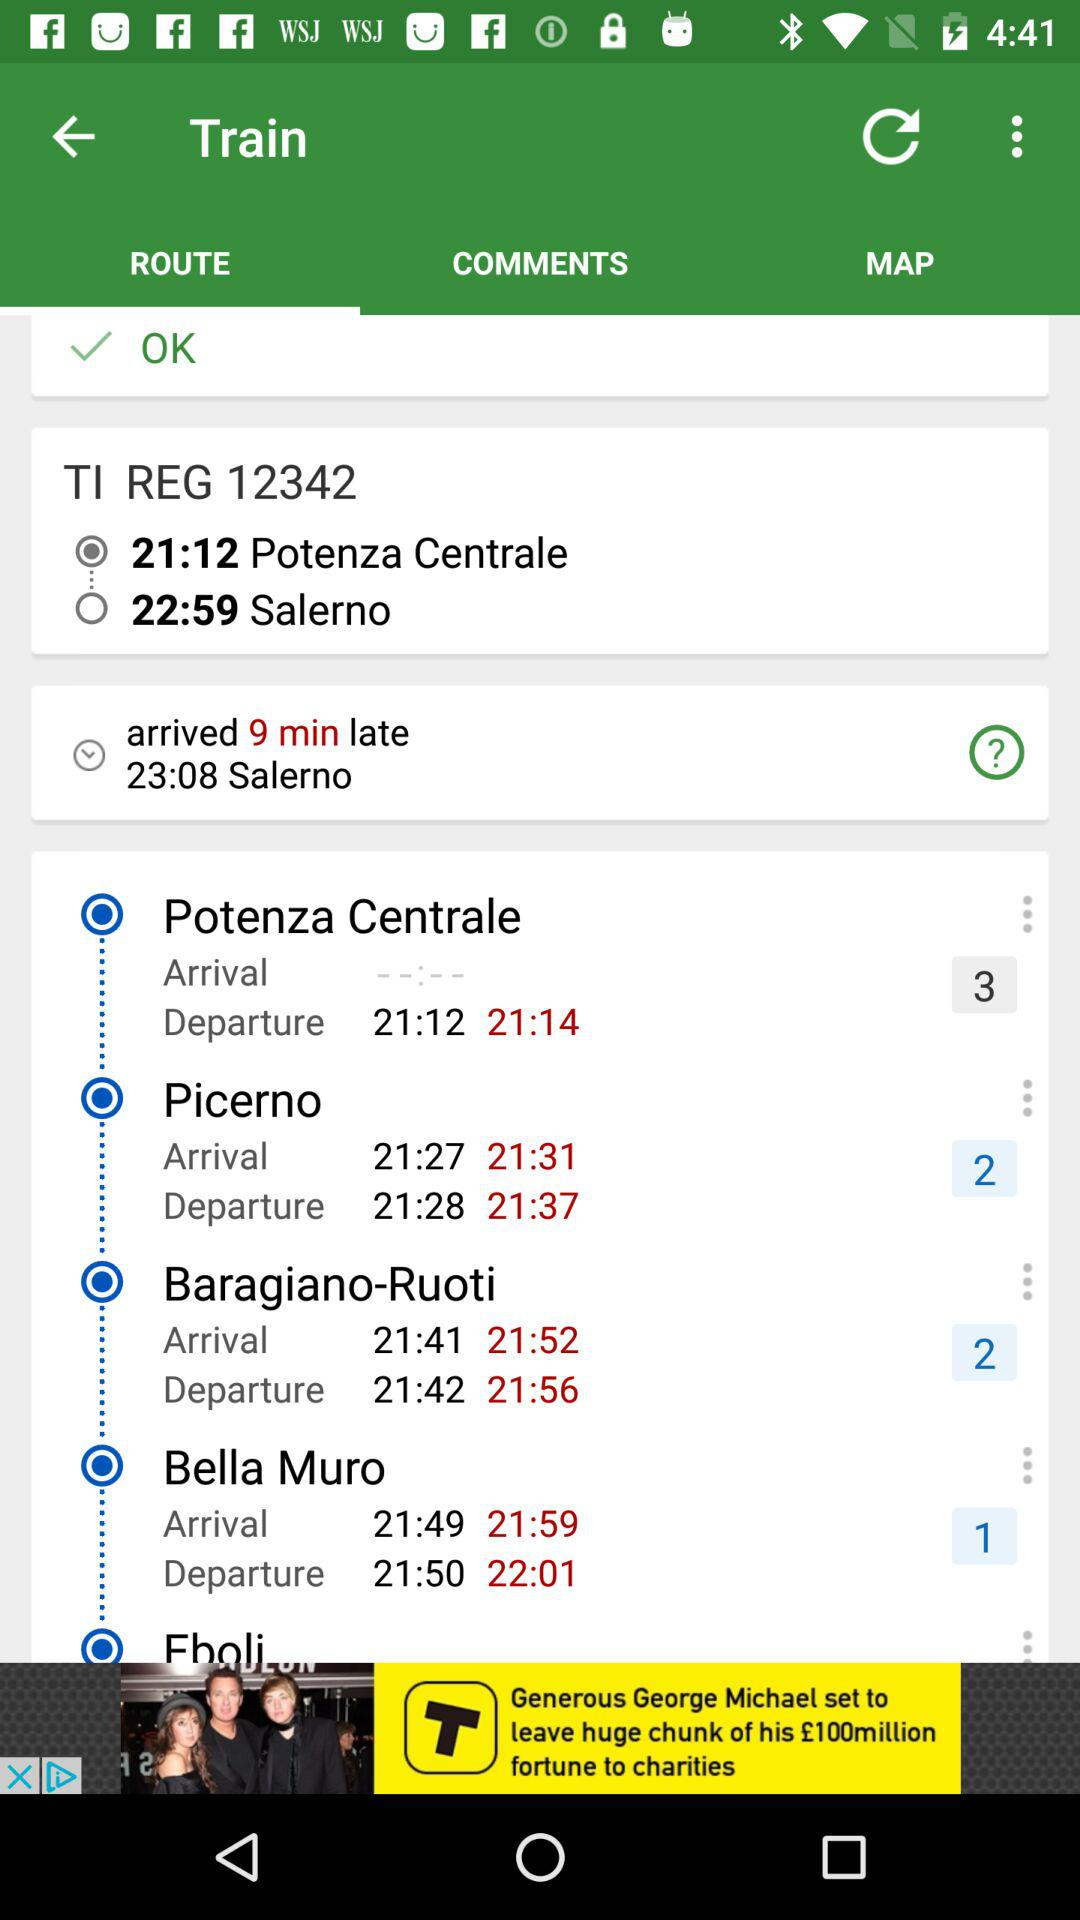How many comments are there?
When the provided information is insufficient, respond with <no answer>. <no answer> 